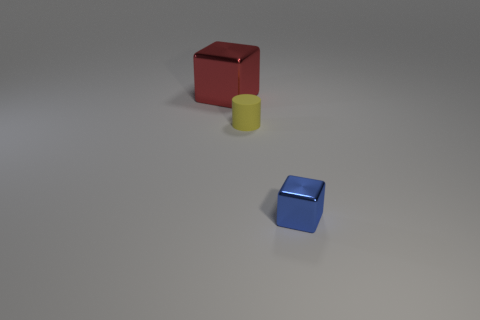Add 1 cyan matte spheres. How many objects exist? 4 Subtract all cylinders. How many objects are left? 2 Subtract 0 purple cylinders. How many objects are left? 3 Subtract all small blue metal objects. Subtract all blue objects. How many objects are left? 1 Add 2 yellow objects. How many yellow objects are left? 3 Add 3 tiny blue rubber cubes. How many tiny blue rubber cubes exist? 3 